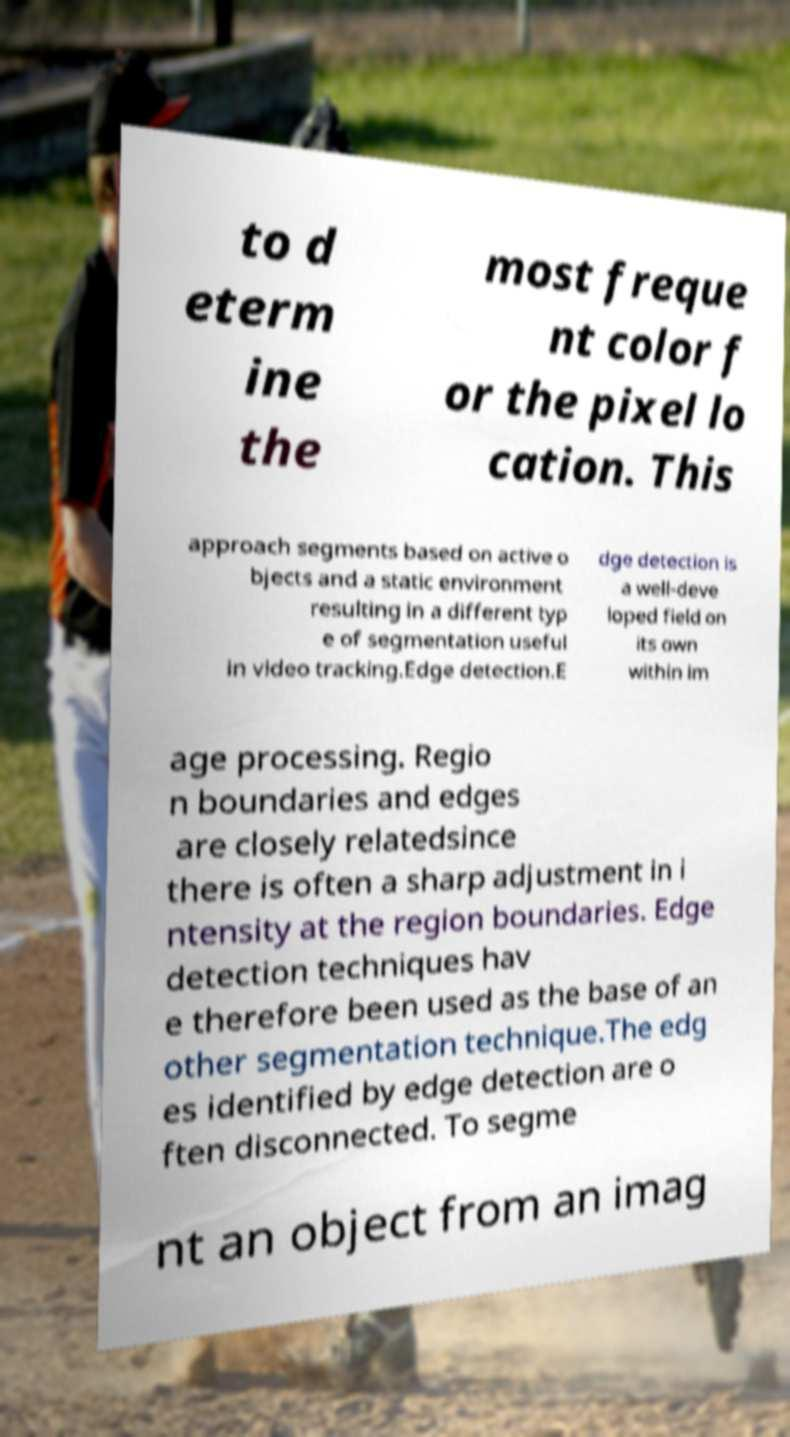What messages or text are displayed in this image? I need them in a readable, typed format. to d eterm ine the most freque nt color f or the pixel lo cation. This approach segments based on active o bjects and a static environment resulting in a different typ e of segmentation useful in video tracking.Edge detection.E dge detection is a well-deve loped field on its own within im age processing. Regio n boundaries and edges are closely relatedsince there is often a sharp adjustment in i ntensity at the region boundaries. Edge detection techniques hav e therefore been used as the base of an other segmentation technique.The edg es identified by edge detection are o ften disconnected. To segme nt an object from an imag 